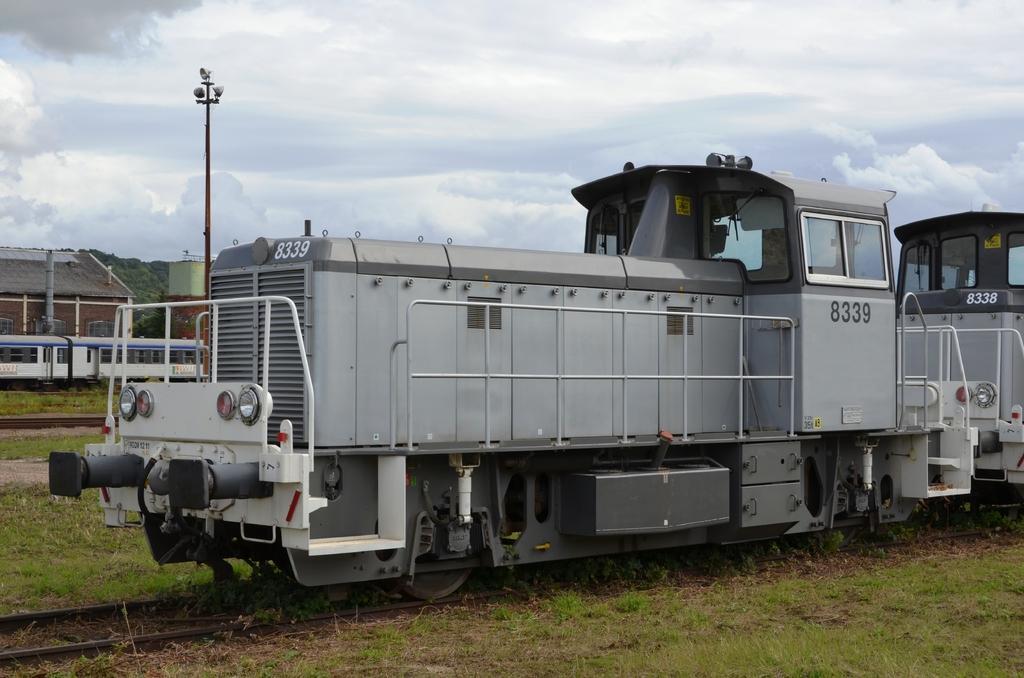In one or two sentences, can you explain what this image depicts? In this image we can see the trains on the railway track. We can also see the grass, light pole, houses and also the sky with the clouds. 